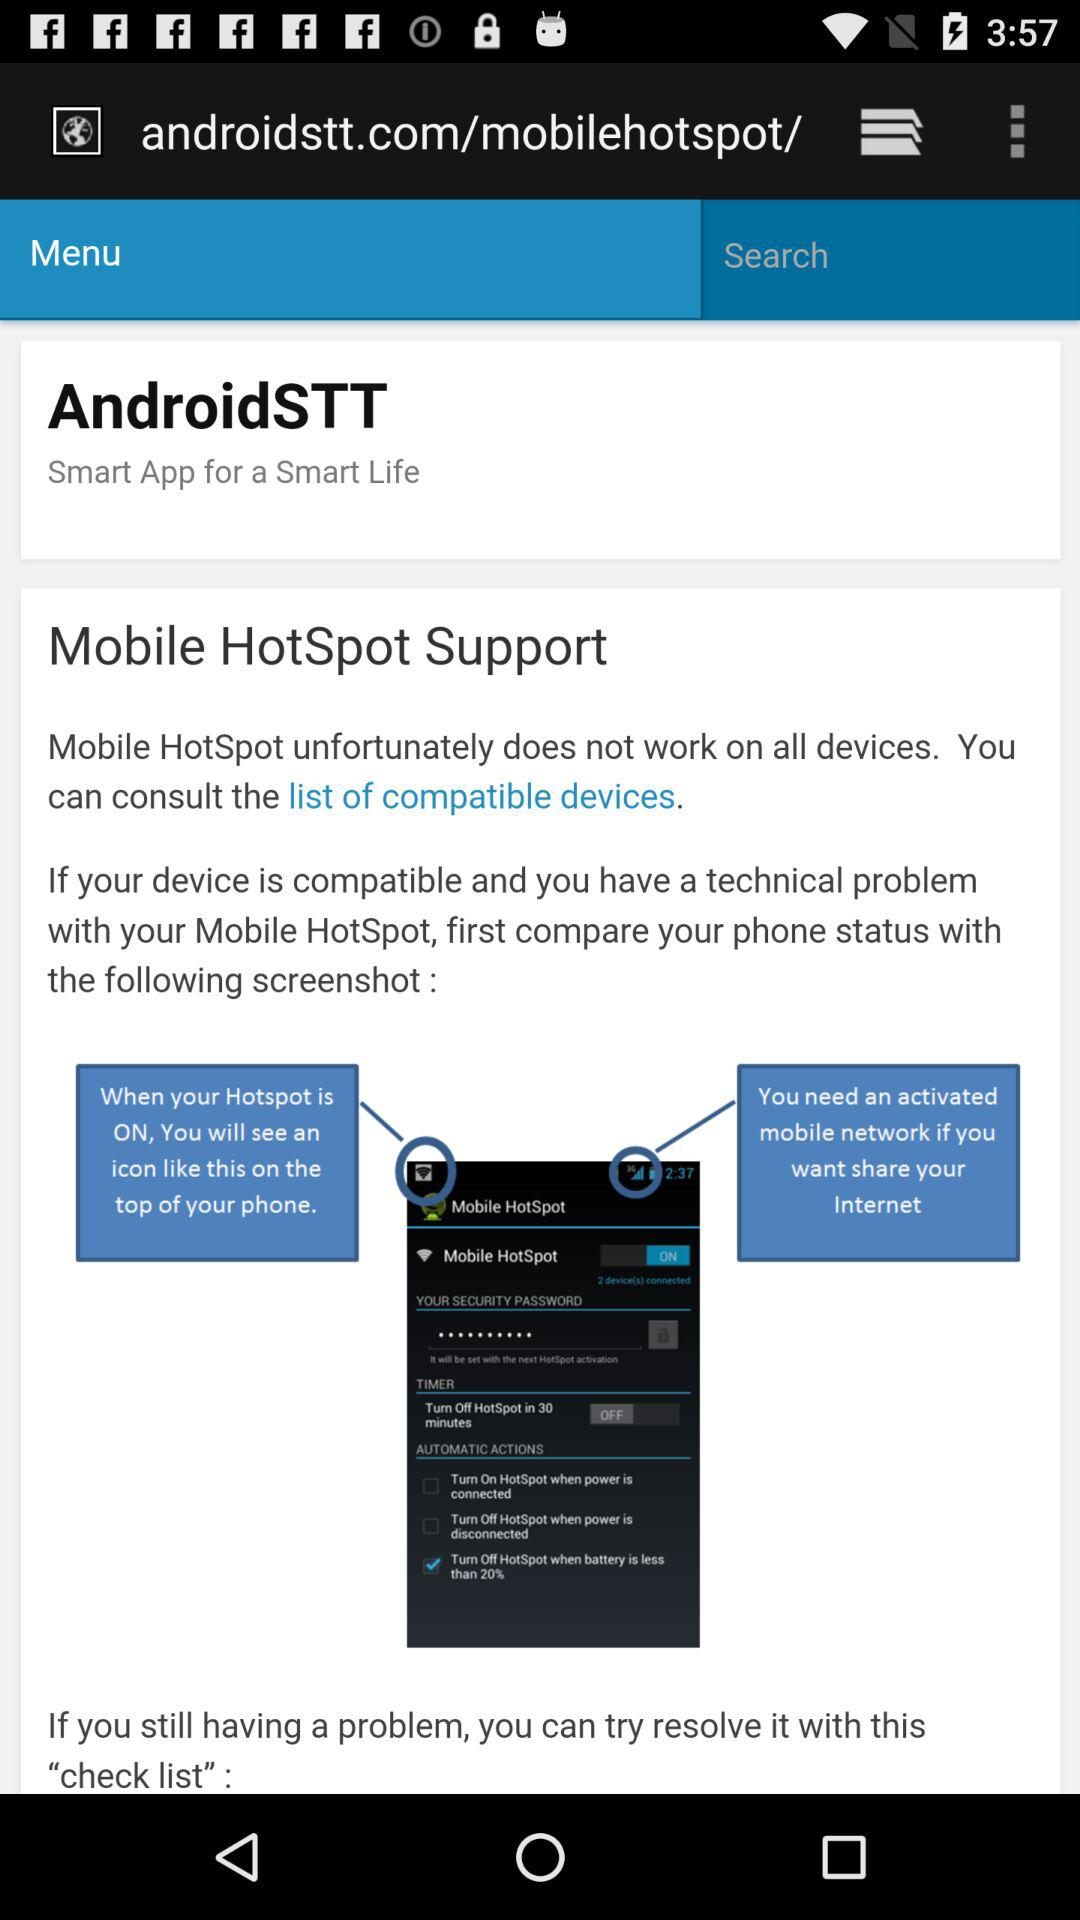What is the application name? The application name is "Mobile HotSpot". 